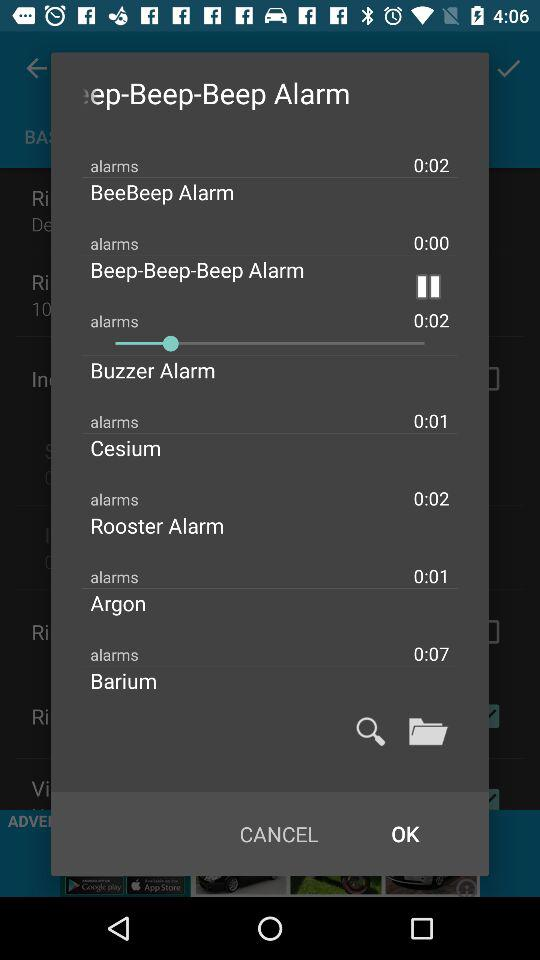How many alarms have a duration of 0:01?
Answer the question using a single word or phrase. 2 